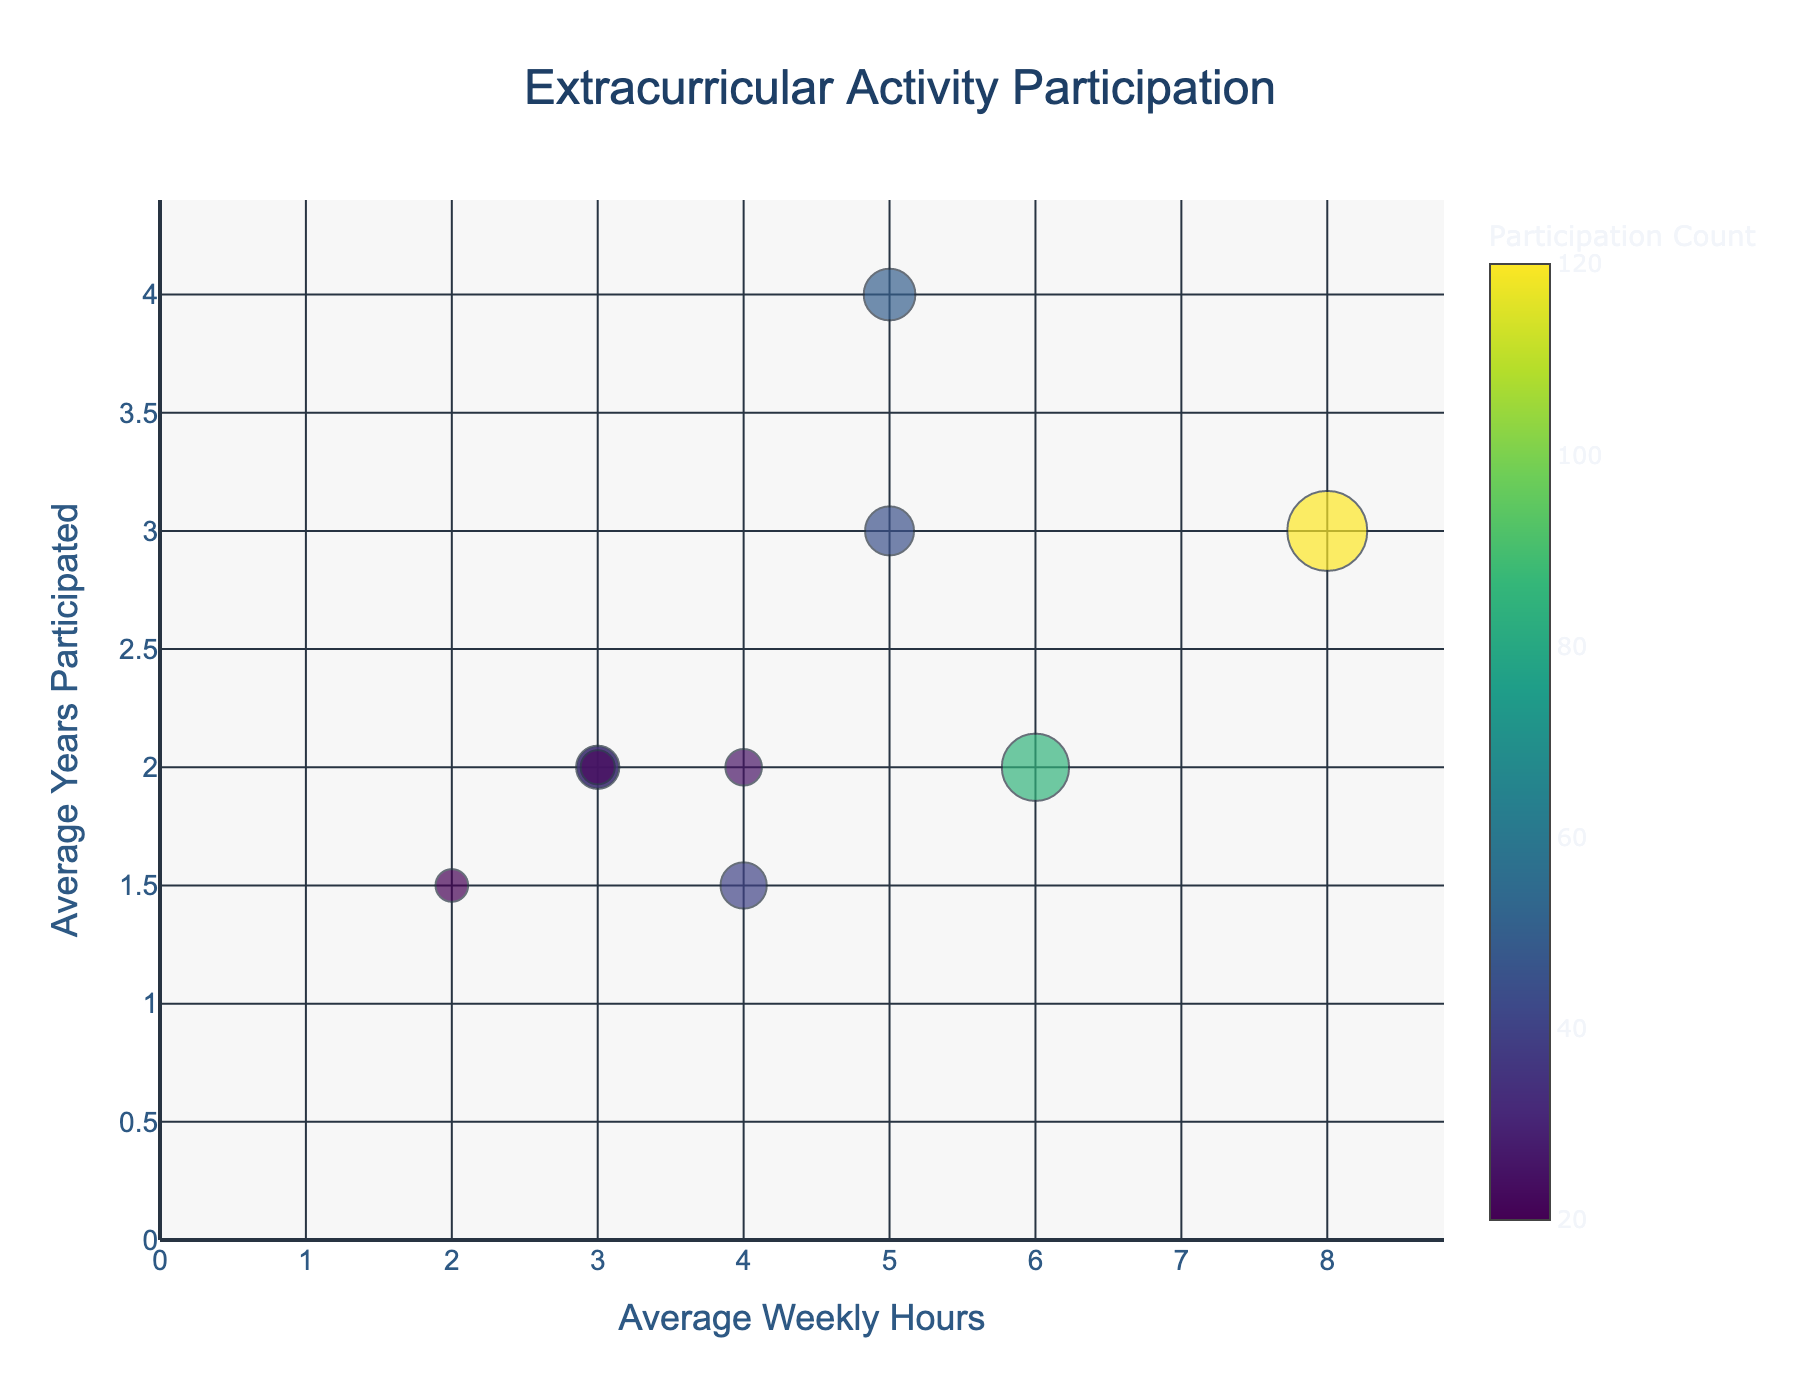What is the title of the figure? The title of the figure is generally located at the top center of the chart and is formatted to be larger and more prominent than other text elements. The title gives us a quick summary of what the figure is about.
Answer: Extracurricular Activity Participation Which activity has the highest participation count? To find this, look at the largest bubble on the chart. The bubble size is proportional to the participation count.
Answer: Soccer What is the average weekly hours for Choir? Find the bubble labeled 'Choir' and check its position on the x-axis, which represents the average weekly hours.
Answer: 5 Which activity has the smallest average weekly hours and what is that value? Look at the leftmost bubble on the x-axis, as this axis represents the average weekly hours.
Answer: Art Club, 2 How many activities have average weekly hours greater than 4? Count the number of bubbles situated to the right of the x-axis value of 4.
Answer: 4 Which activity has participated in for the longest average years? Look for the highest bubble on the y-axis since this axis represents the average years participated.
Answer: Band Compare the average years participated between Soccer and Basketball. Which one is higher and by how much? Locate the 'Soccer' and 'Basketball' bubbles and read their positions on the y-axis to find the average years participated, then subtract the smaller value from the larger value.
Answer: Soccer, by 1 year Which activity has fewer participants, Chess Club or Math Club? Look at the relative bubble sizes for 'Chess Club' and 'Math Club' since the bubble size represents participation count.
Answer: Chess Club What is the color scale used in the chart and what does it represent? The color scale is shown in the color bar alongside the chart. It typically ranges from one color at a low value to another at a high value. This scale represents the participation count.
Answer: Viridis, Participation Count Calculate the total participation count for Drama Club, Band, and Science Olympiad. Sum the participation counts for 'Drama Club', 'Band', and 'Science Olympiad' from the color bar or bubble size information.
Answer: 40 + 50 + 25 = 115 